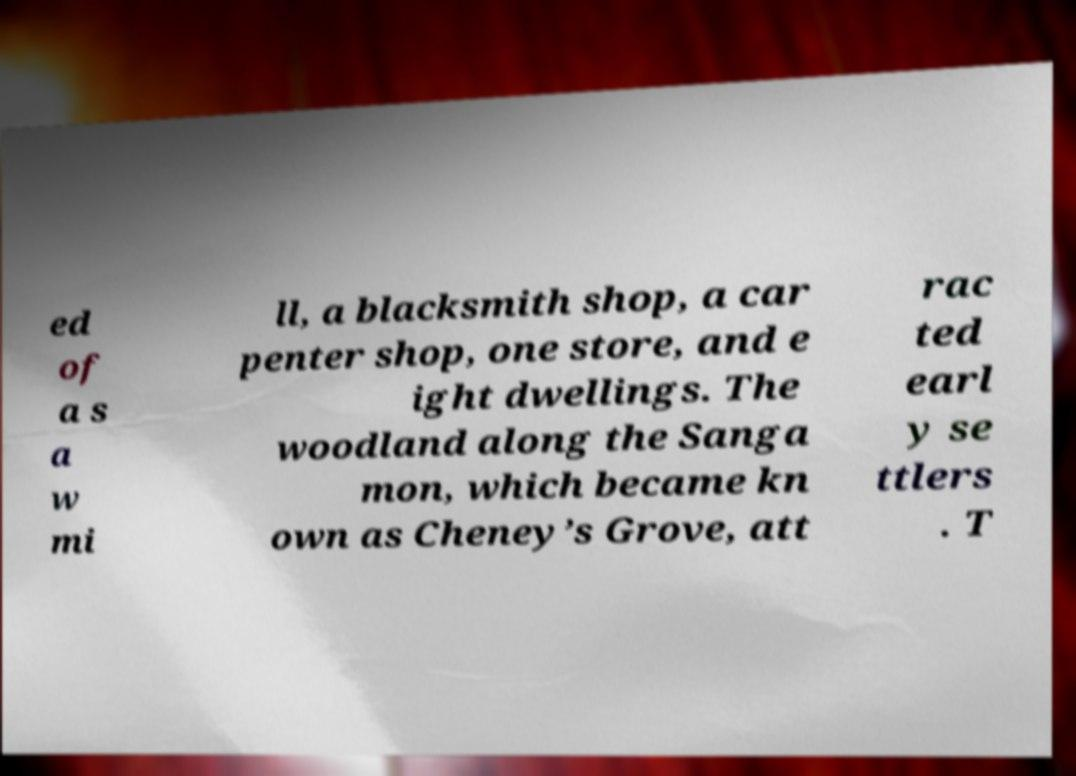Could you extract and type out the text from this image? ed of a s a w mi ll, a blacksmith shop, a car penter shop, one store, and e ight dwellings. The woodland along the Sanga mon, which became kn own as Cheney’s Grove, att rac ted earl y se ttlers . T 